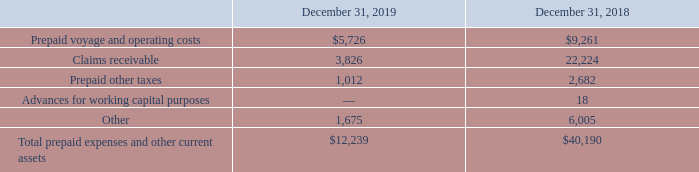NAVIOS MARITIME HOLDINGS INC. NOTES TO THE CONSOLIDATED FINANCIAL STATEMENTS (Expressed in thousands of U.S. dollars — except share data)
NOTE 6: PREPAID EXPENSES AND OTHER CURRENT ASSETS
Prepaid expenses and other current assets consisted of the following:
Claims receivable mainly represents claims against vessels’ insurance underwriters in respect of damages arising from accidents or other insured risks, as well as claims under charter contracts including off-hires. While it is anticipated that claims receivable will be recovered within one year, such claims may not all be recovered within one year due to the attendant process of settlement. Nonetheless, amounts are classified as current as they represent amounts currently due to the Company. All amounts are shown net of applicable deductibles.
As of December 31, 2018, claims receivable include $11,571 related to insurance claim at the iron ore port terminal in Nueva Palmira, Uruguay.
What does claims receivable represent?  Claims against vessels’ insurance underwriters in respect of damages arising from accidents or other insured risks, as well as claims under charter contracts including off-hires. Which years does the table provide information for Prepaid expenses and other current assets? 2019, 2018. What were the prepaid other taxes in 2019?
Answer scale should be: thousand. 1,012. How many years did Total prepaid expenses and other current assets exceed $20,000 thousand? 2018
Answer: 1. What was the change in claims receivable between 2018 and 2019?
Answer scale should be: thousand. 3,826-22,224
Answer: -18398. What was the percentage change in other current assets between 2018 and 2019?
Answer scale should be: percent. (1,675-6,005)/6,005
Answer: -72.11. 